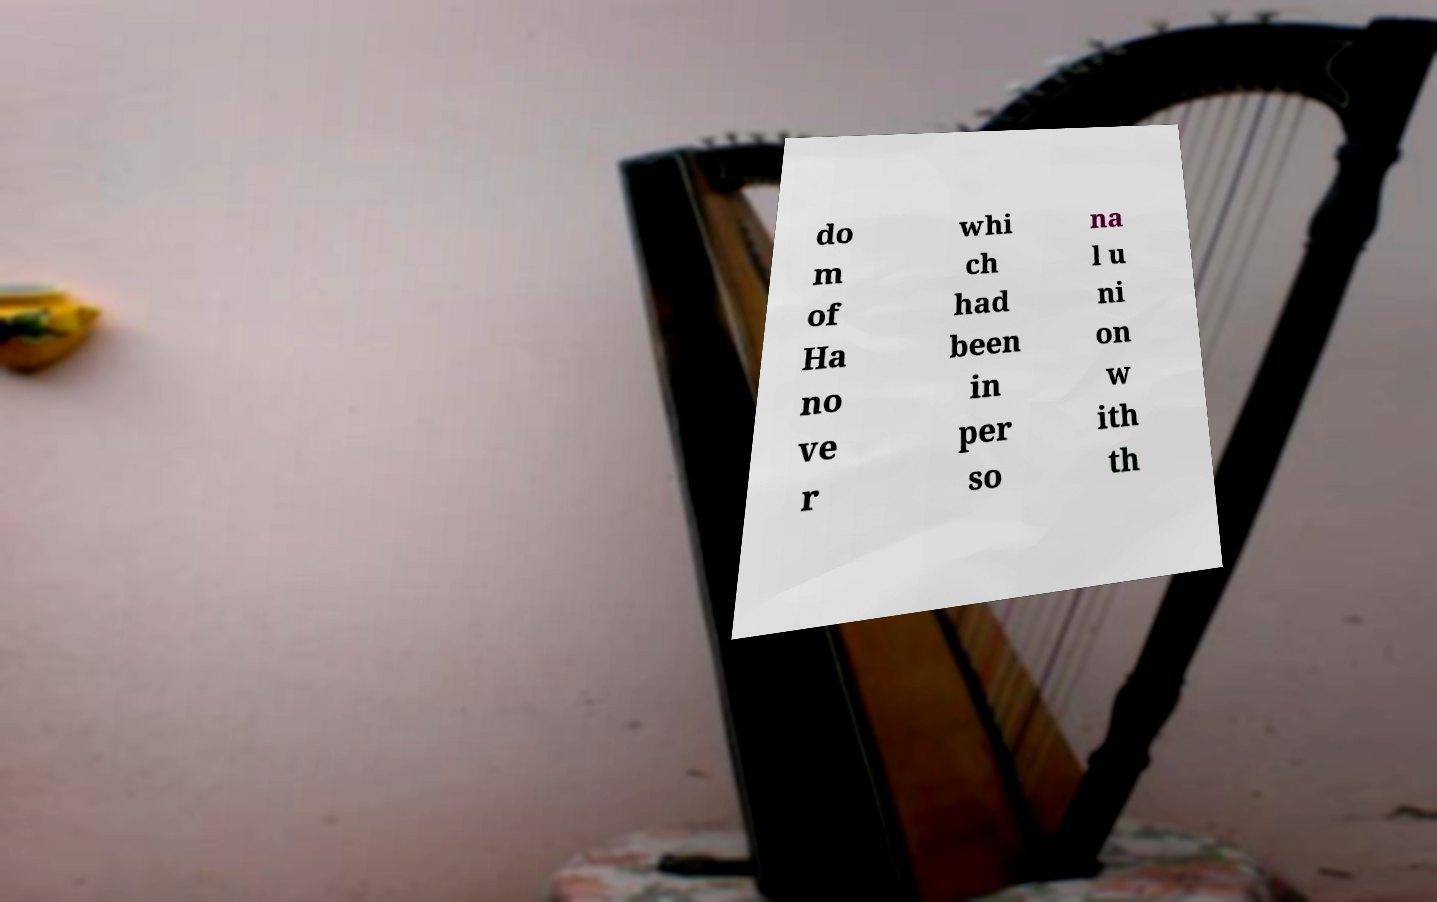Can you accurately transcribe the text from the provided image for me? do m of Ha no ve r whi ch had been in per so na l u ni on w ith th 